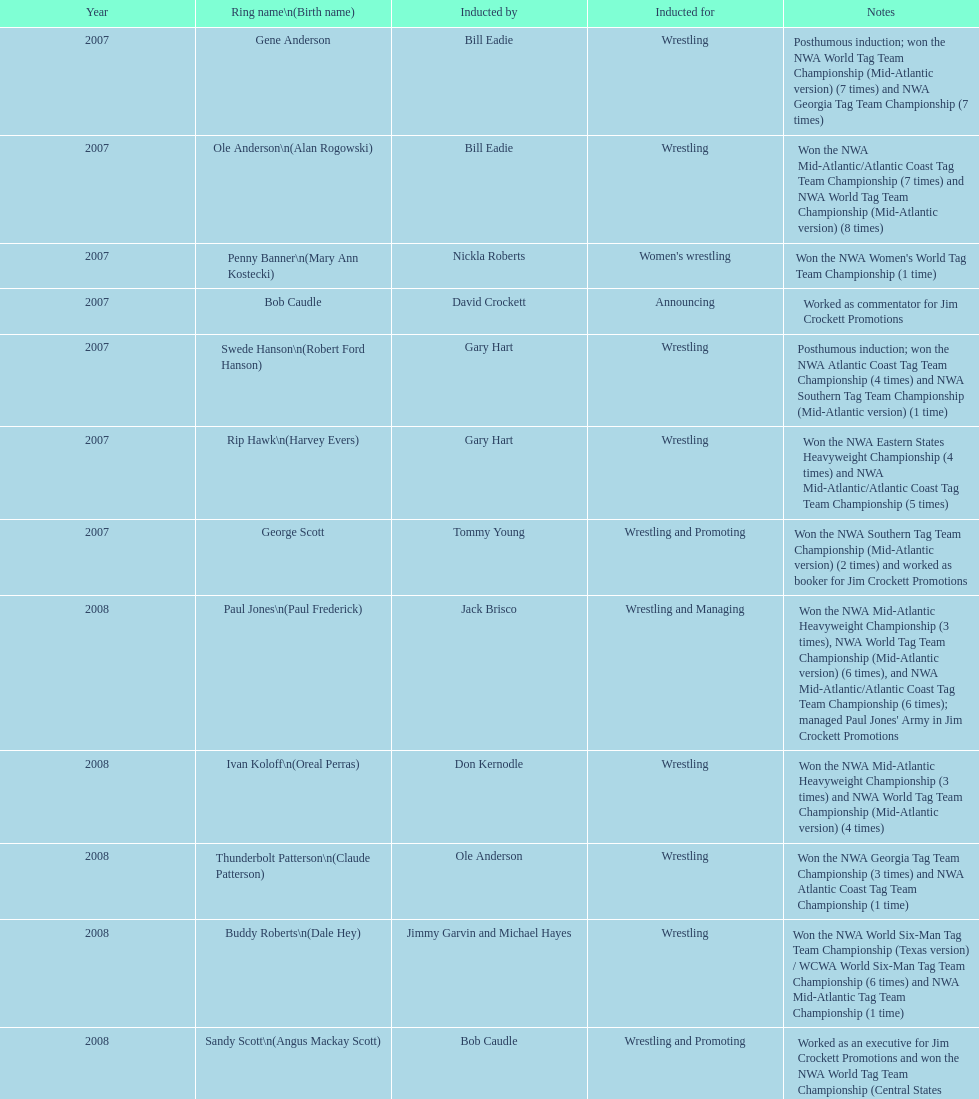Who was the exclusive inductee for both wrestling and management roles? Paul Jones. 